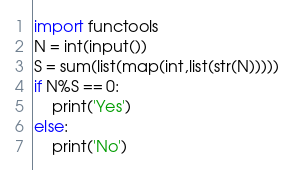<code> <loc_0><loc_0><loc_500><loc_500><_Python_>import functools
N = int(input())
S = sum(list(map(int,list(str(N)))))
if N%S == 0:
    print('Yes')
else:
    print('No')</code> 